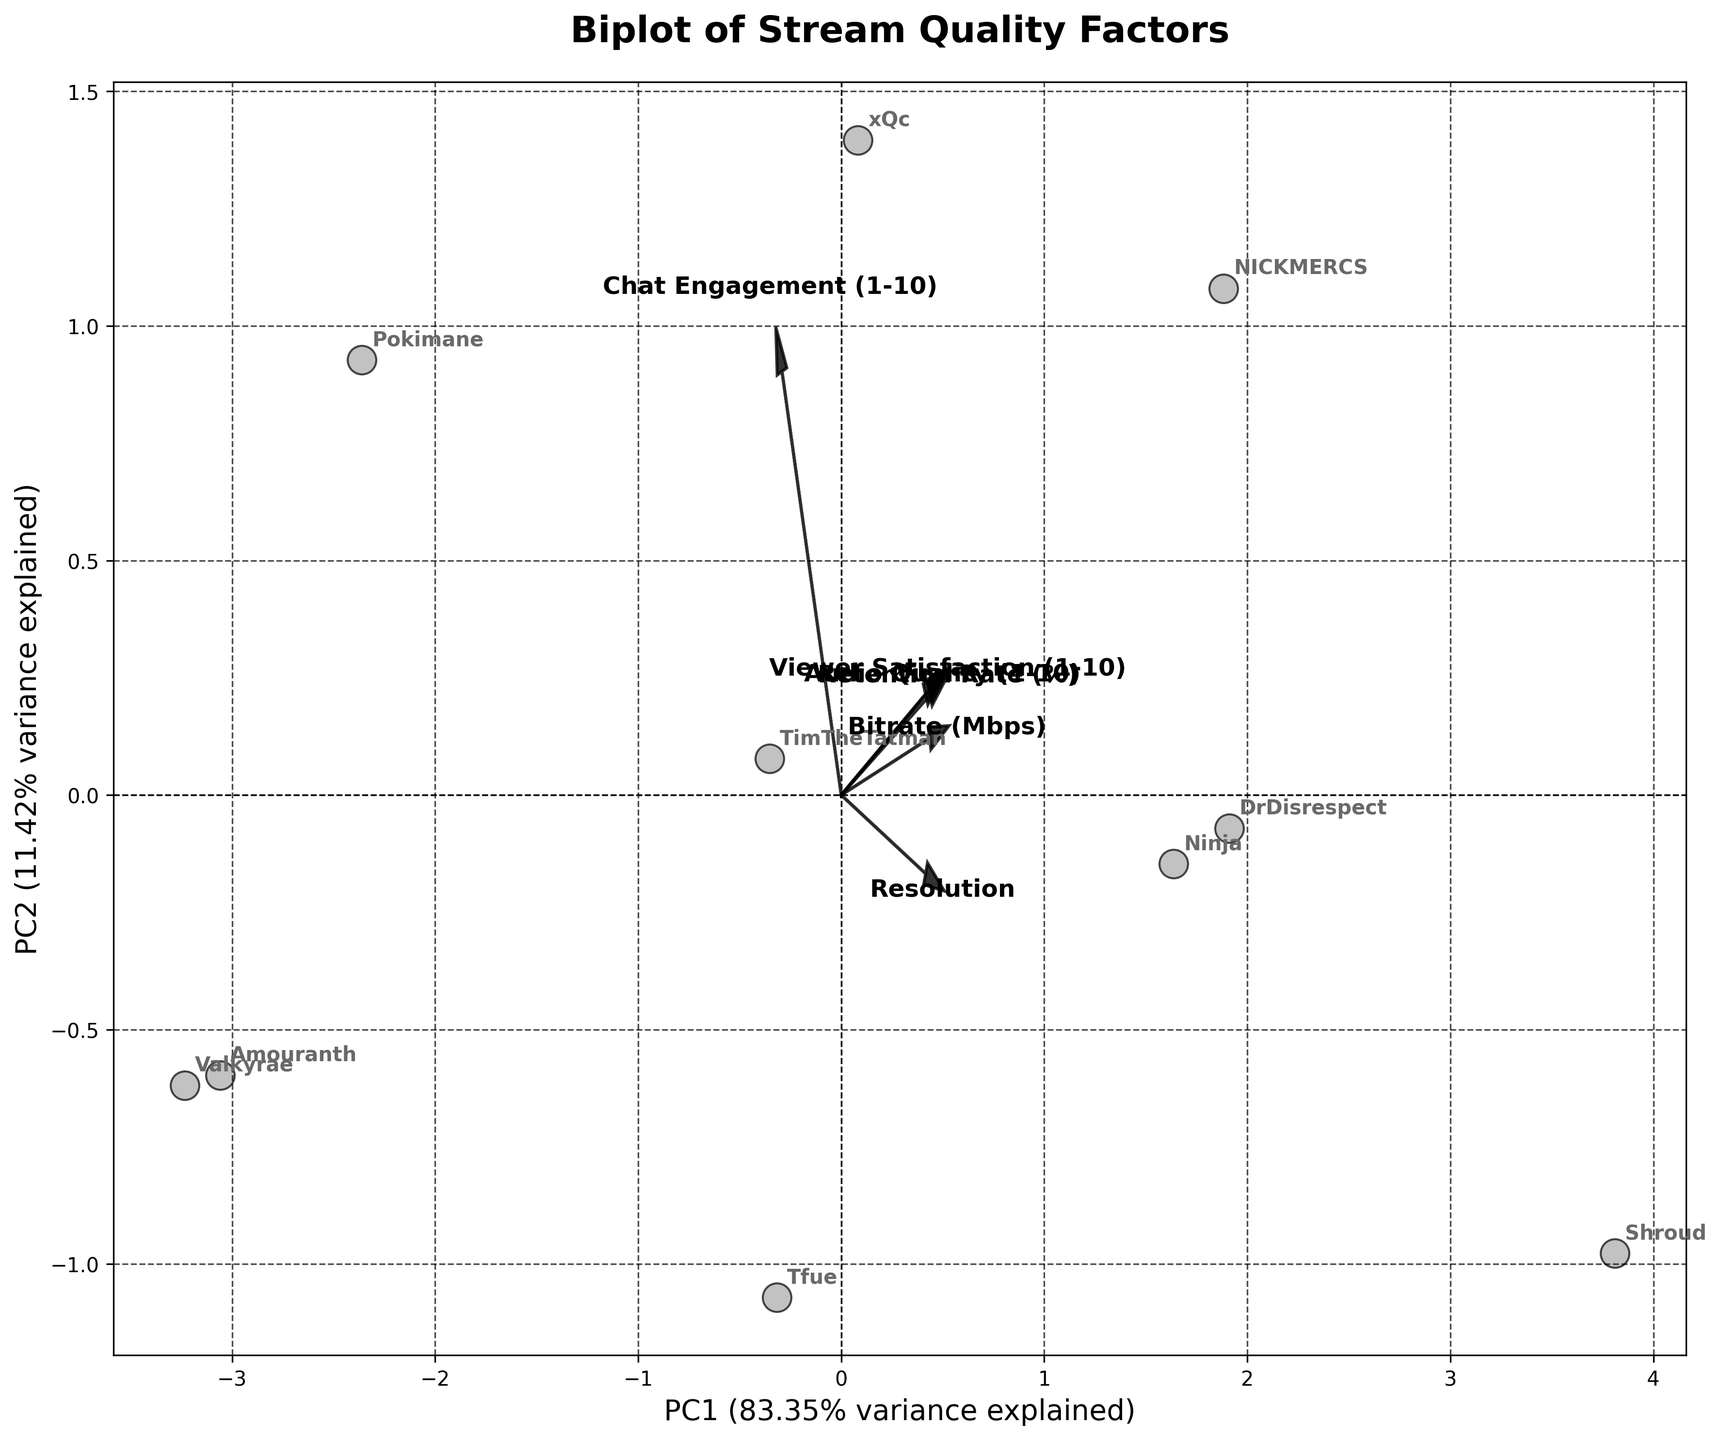What's the title of the plot? The title of the plot is displayed at the top of the figure, usually using a larger font size and bold formatting to stand out.
Answer: Biplot of Stream Quality Factors How many different streams are represented in the plot? By counting the annotated labels corresponding to each data point on the biplot, we can determine the number of different streams represented.
Answer: 10 Which stream appears closest to the arrow representing "Audio Quality (1-10)"? Observing the biplot, the stream whose data point is nearest to the direction of the arrow labeled "Audio Quality (1-10)" can be identified.
Answer: Shroud What percentage of variance is explained by the first principal component (PC1)? The percentage of variance explained by the first principal component is typically provided in the labels of the axes.
Answer: ~40% Between Pokimane and Shroud, which stream has a higher retention rate? By inspecting the data points' positions along the axis related to "Retention Rate (%)" and considering their annotations, we can compare the two streams.
Answer: Shroud Which feature shows the highest loading on the first principal component (PC1)? The feature with the highest loading on PC1 can be identified by examining the length and direction of the arrows from the origin along the PC1 axis.
Answer: Viewer Satisfaction Is "Resolution" positively correlated with "Audio Quality (1-10)" according to the plot? To determine the correlation, we observe the direction of the arrows for "Resolution" and "Audio Quality (1-10)"—if they point in similar directions, they are positively correlated.
Answer: Yes What is the combined variance explained by the first two principal components? The combined variance is the sum of the variances explained by PC1 and PC2, which can be found in the axis labels.
Answer: ~70% Which stream has the lowest viewer satisfaction and where is it located on the plot? By identifying the stream with the lowest score in the "Viewer Satisfaction (1-10)" feature and locating its corresponding data point on the biplot.
Answer: Amouranth, bottom left What's the general trend between "Bitrate (Mbps)" and retention rate on the plot? Observing the direction and position of the arrows for "Bitrate (Mbps)" and "Retention Rate (%)" highlights the trend—both pointing in the same or opposite direction suggests the nature of their relationship.
Answer: Positive correlation 